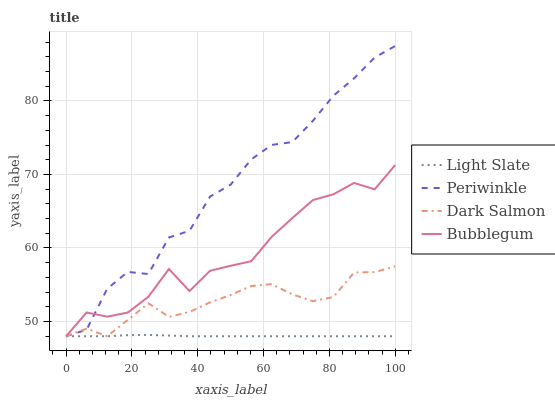Does Light Slate have the minimum area under the curve?
Answer yes or no. Yes. Does Periwinkle have the maximum area under the curve?
Answer yes or no. Yes. Does Dark Salmon have the minimum area under the curve?
Answer yes or no. No. Does Dark Salmon have the maximum area under the curve?
Answer yes or no. No. Is Light Slate the smoothest?
Answer yes or no. Yes. Is Periwinkle the roughest?
Answer yes or no. Yes. Is Dark Salmon the smoothest?
Answer yes or no. No. Is Dark Salmon the roughest?
Answer yes or no. No. Does Dark Salmon have the highest value?
Answer yes or no. No. 